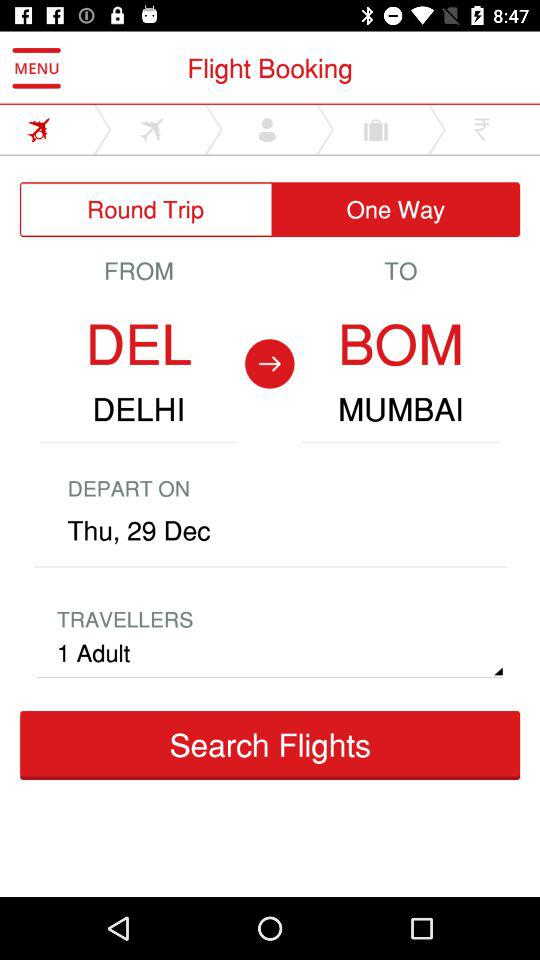For how many passengers will the ticket be booked? The ticket will be booked for 1 passenger. 